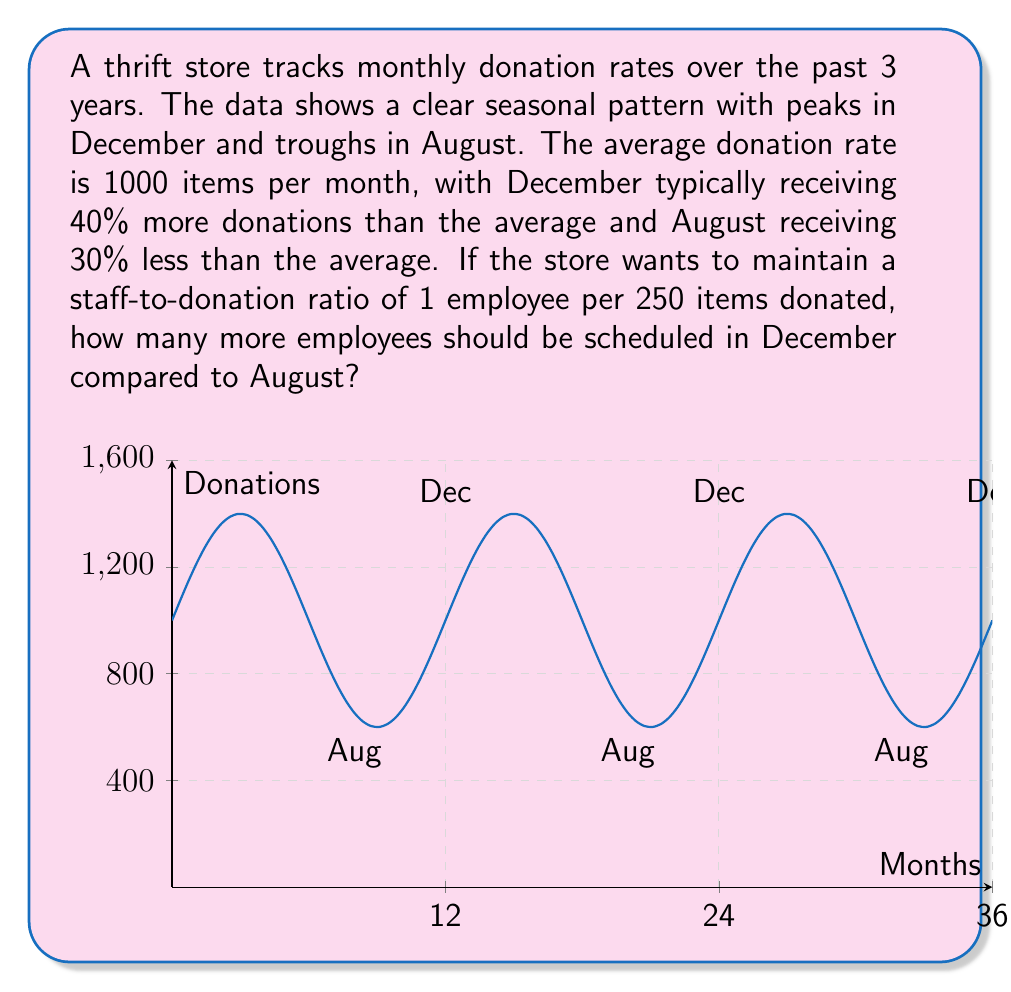Could you help me with this problem? Let's approach this step-by-step:

1) First, calculate the donation rates for December and August:

   December: 140% of average = $1000 \times 1.40 = 1400$ items
   August: 70% of average = $1000 \times 0.70 = 700$ items

2) Now, calculate the number of employees needed for each month:

   For December: $\frac{1400 \text{ items}}{250 \text{ items/employee}} = 5.6$ employees
   For August: $\frac{700 \text{ items}}{250 \text{ items/employee}} = 2.8$ employees

3) Since we can't have fractional employees, we round up to the nearest whole number:

   December needs 6 employees
   August needs 3 employees

4) The difference in staffing between December and August is:

   $6 - 3 = 3$ employees

Therefore, 3 more employees should be scheduled in December compared to August.
Answer: 3 employees 